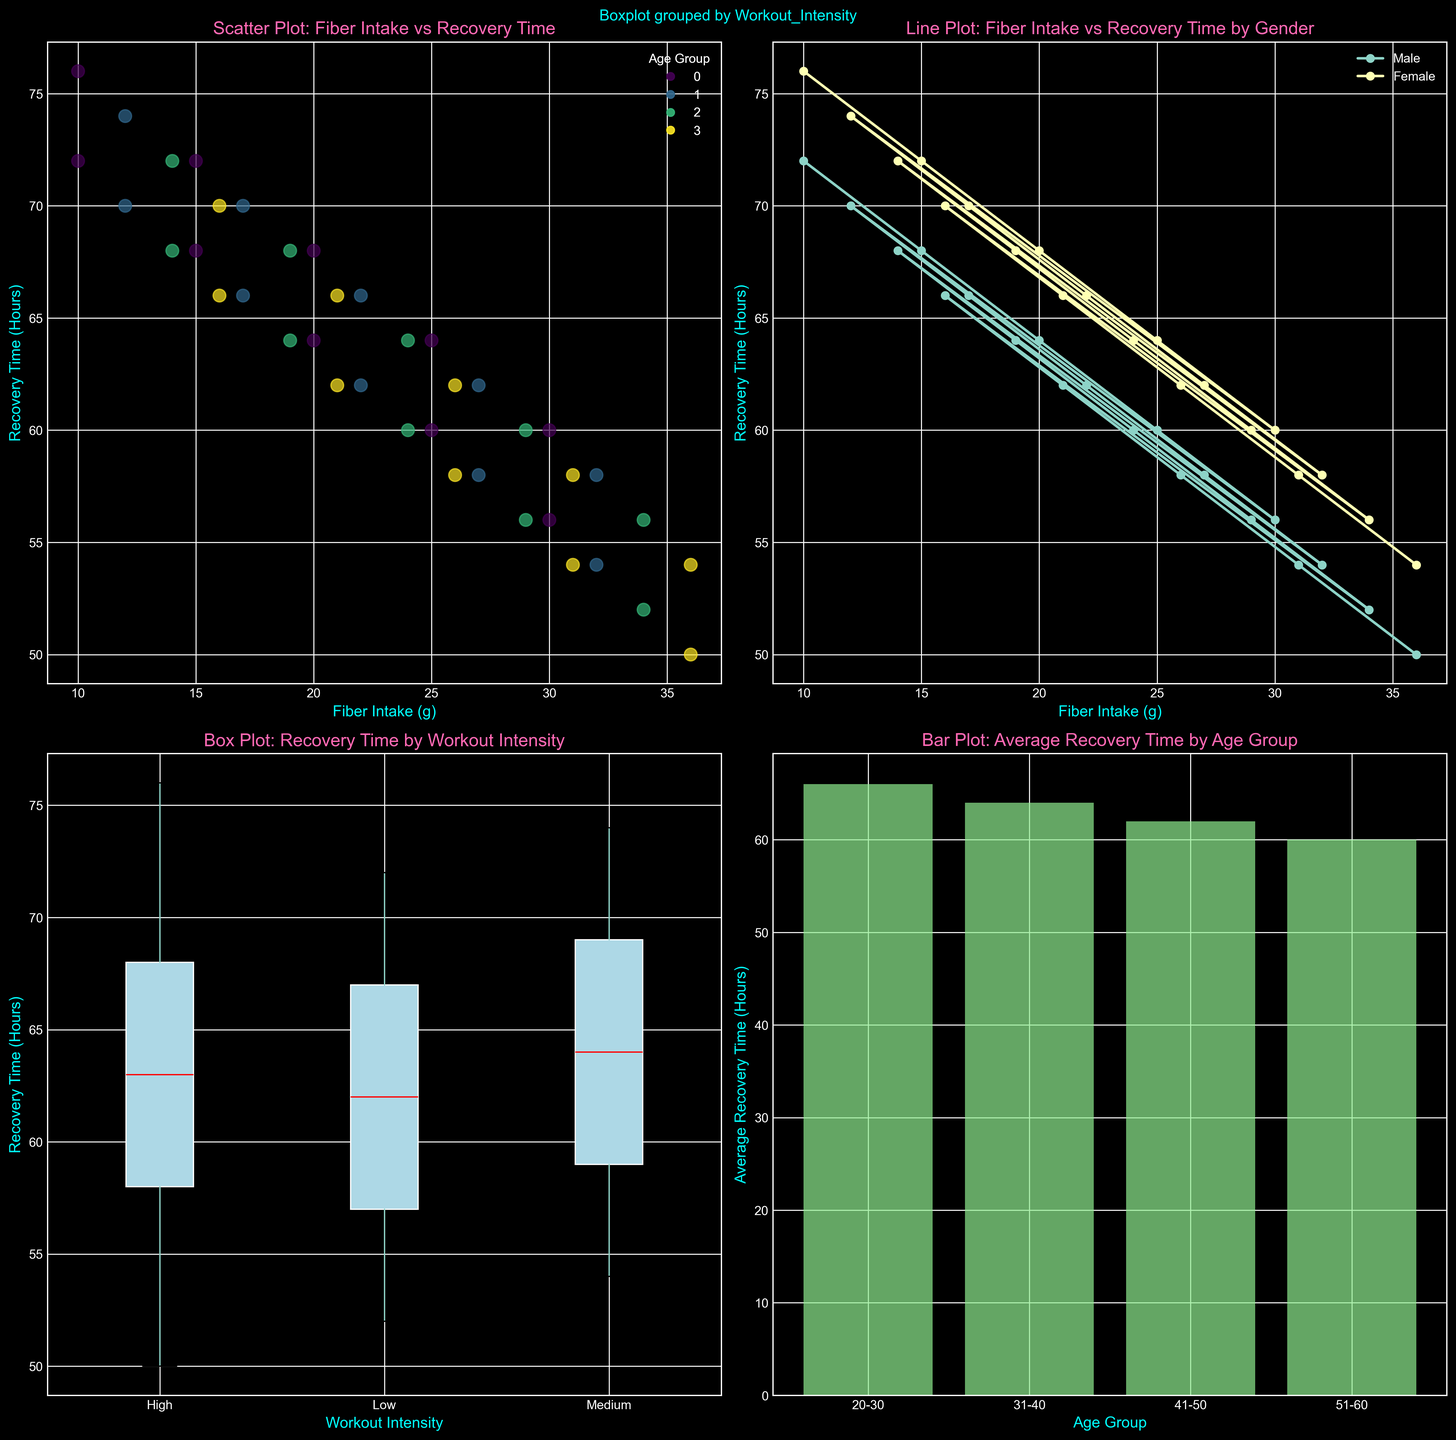What's the average recovery time for the age group 31-40? To find this, refer to the bar plot in the bottom-right corner. Look for the bar labeled "31-40" and note the height, which represents the average recovery time for this group.
Answer: 64 hours Which gender shows a steeper decline in recovery time with increasing fiber intake in the line plot? Refer to the line plot in the top-right corner. Compare the slopes of the lines for "Male" and "Female". The steeper line (greater change in y-axis per unit x-axis) indicates the gender with a steeper decline.
Answer: Male What is the average recovery time across all age groups in the dataset? Using the bar plot, sum the average recovery times for each age group, then divide by the number of age groups. (68 + 66 + 62 + 60)/4 = 64
Answer: 64 hours What is the difference in recovery time between high and low workout intensity, according to the box plot? Look at the median lines in the box plot for "High" and "Low" workout intensities. Measure the difference between these median values.
Answer: 8 hours Which age group has the highest average recovery time? Refer to the bar plot and identify the bar with the greatest height.
Answer: 20-30 In the scatter plot, which age group has the most data points? Look at the legend explaining color coding for age groups. Determine which color is most frequently appearing as dots in the scatter plot.
Answer: 20-30 Which group generally has faster recovery times based on gender, according to the line plot? Observe the y-axis values corresponding to the fiber intake on the line plot for both genders. The gender with lower y-values (recovery time) most frequently indicates faster recovery.
Answer: Male How does the median recovery time for medium workout intensity compare to high and low intensity in the box plot? Check the positions of the median lines for the box plots of "Medium," "High," and "Low" and compare their y-values.
Answer: Between High and Low What's the range of recovery times for the low workout intensity group? In the box plot for "Low" intensity, look at the highest and lowest points (whiskers) and calculate the difference between them.
Answer: 52 - 72 hours (20 hours) In the scatter plot, does higher fiber intake correlate with lower recovery time? Check the trend of points from left (low fiber intake) to right (high fiber intake) and see if the recovery time (y-axis) decreases as fiber intake increases.
Answer: Yes 